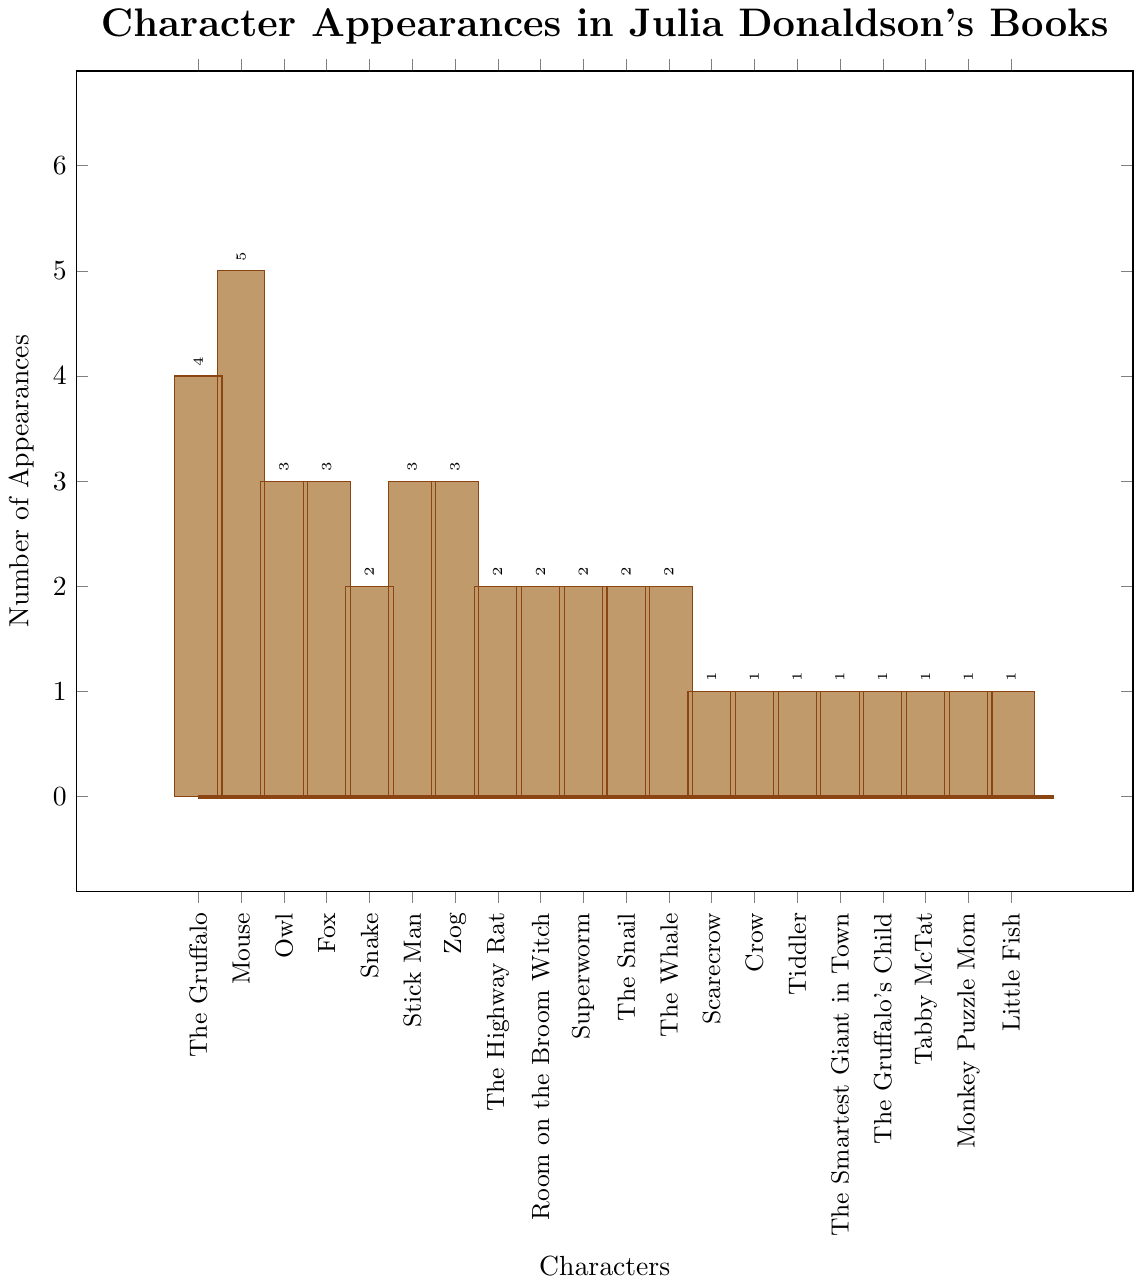What character appears the most frequently in Julia Donaldson's books? The bar that represents the Mouse is the tallest, reaching the highest value on the y-axis. This bar indicates that the Mouse appears the most frequently with a value of 5.
Answer: Mouse How many characters appear exactly twice in the books? To determine how many characters appear exactly twice, count the bars that reach the value of 2 on the y-axis. Five characters (Snake, The Highway Rat, Room on the Broom Witch, Superworm, The Snail, and The Whale) have a height at 2.
Answer: 6 Which character appears more frequently: the Fox or the Snake? By comparing the heights of the bars representing the Fox and the Snake, the Fox bar reaches the value of 3 while the Snake bar reaches the value of 2. Thus, the Fox appears more frequently.
Answer: Fox What is the total number of appearances for all characters combined? Sum the heights of all the bars: 4 (The Gruffalo) + 5 (Mouse) + 3 (Owl) + 3 (Fox) + 2 (Snake) + 3 (Stick Man) + 3 (Zog) + 2 (The Highway Rat) + 2 (Room on the Broom Witch) + 2 (Superworm) + 2 (The Snail) + 2 (The Whale) + 1 (Scarecrow) + 1 (Crow) + 1 (Tiddler) + 1 (The Smartest Giant in Town) + 1 (The Gruffalo's Child) + 1 (Tabby McTat) + 1 (Monkey Puzzle Mom) + 1 (Little Fish) = 40.
Answer: 40 Which character's bar color is the same as The Gruffalo's bar? By examining the visual attributes such as the color, it is evident that all bars have the same color, which is a shade of brown. Thus, every character’s bar color is the same as The Gruffalo’s.
Answer: All characters Is there any character that appears in the same number of books as the Stick Man? Locate the height of the Stick Man's bar, which is 3, and then look for any other bars with the same height. The characters Owl, Fox, and Zog also have bars reaching the value of 3.
Answer: Yes, 3 characters What is the difference in the number of appearances between the Mouse and the Gruffalo? The Mouse appears 5 times while the Gruffalo appears 4 times. Subtract the number of Gruffalo's appearances from the Mouse's: 5 - 4 = 1.
Answer: 1 Arrange the characters with the highest number of appearances in ascending order. Identify the characters with the highest appearances: Mouse (5), The Gruffalo (4). Arrange them in ascending order: The Gruffalo, Mouse.
Answer: The Gruffalo, Mouse How many characters appear only once in the books? Count the bars that reach the value of 1 on the y-axis. Eight characters (Scarecrow, Crow, Tiddler, The Smartest Giant in Town, The Gruffalo's Child, Tabby McTat, Monkey Puzzle Mom, Little Fish) have bars at this height.
Answer: 8 